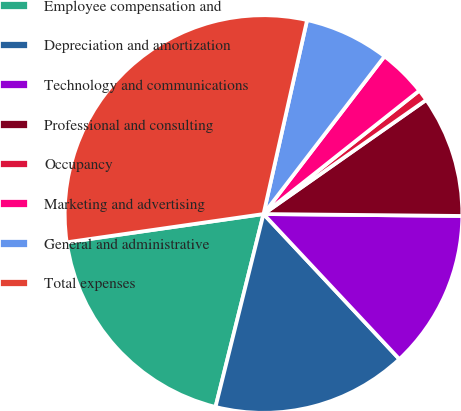Convert chart to OTSL. <chart><loc_0><loc_0><loc_500><loc_500><pie_chart><fcel>Employee compensation and<fcel>Depreciation and amortization<fcel>Technology and communications<fcel>Professional and consulting<fcel>Occupancy<fcel>Marketing and advertising<fcel>General and administrative<fcel>Total expenses<nl><fcel>18.85%<fcel>15.86%<fcel>12.87%<fcel>9.89%<fcel>0.93%<fcel>3.92%<fcel>6.9%<fcel>30.79%<nl></chart> 